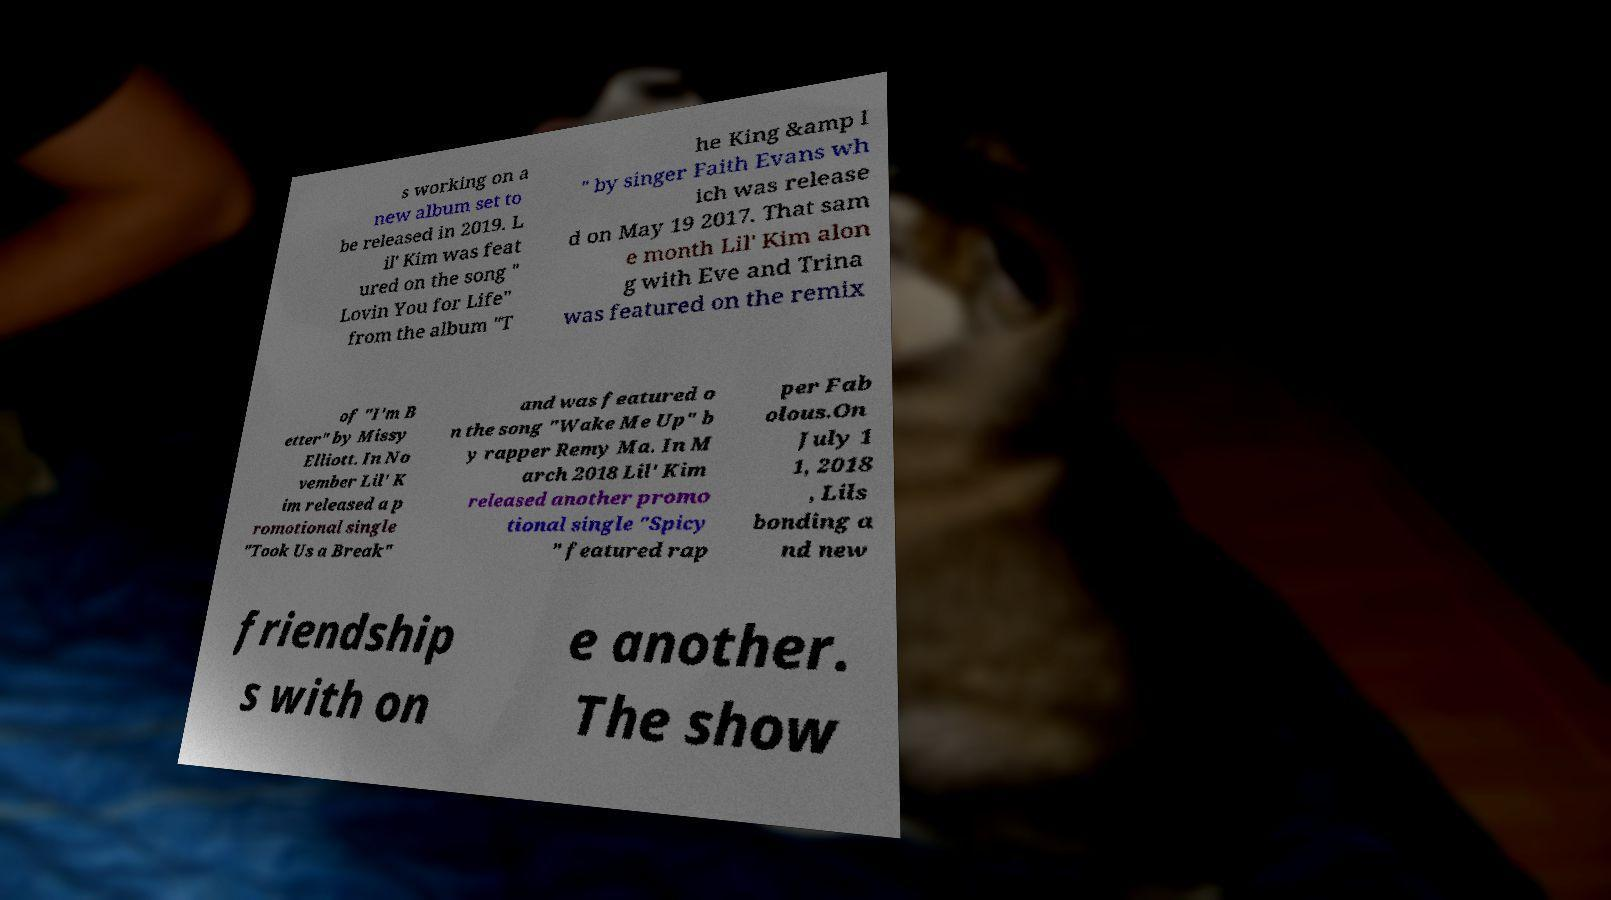Please identify and transcribe the text found in this image. s working on a new album set to be released in 2019. L il' Kim was feat ured on the song " Lovin You for Life" from the album "T he King &amp I " by singer Faith Evans wh ich was release d on May 19 2017. That sam e month Lil' Kim alon g with Eve and Trina was featured on the remix of "I'm B etter" by Missy Elliott. In No vember Lil' K im released a p romotional single "Took Us a Break" and was featured o n the song "Wake Me Up" b y rapper Remy Ma. In M arch 2018 Lil' Kim released another promo tional single "Spicy " featured rap per Fab olous.On July 1 1, 2018 , Lils bonding a nd new friendship s with on e another. The show 